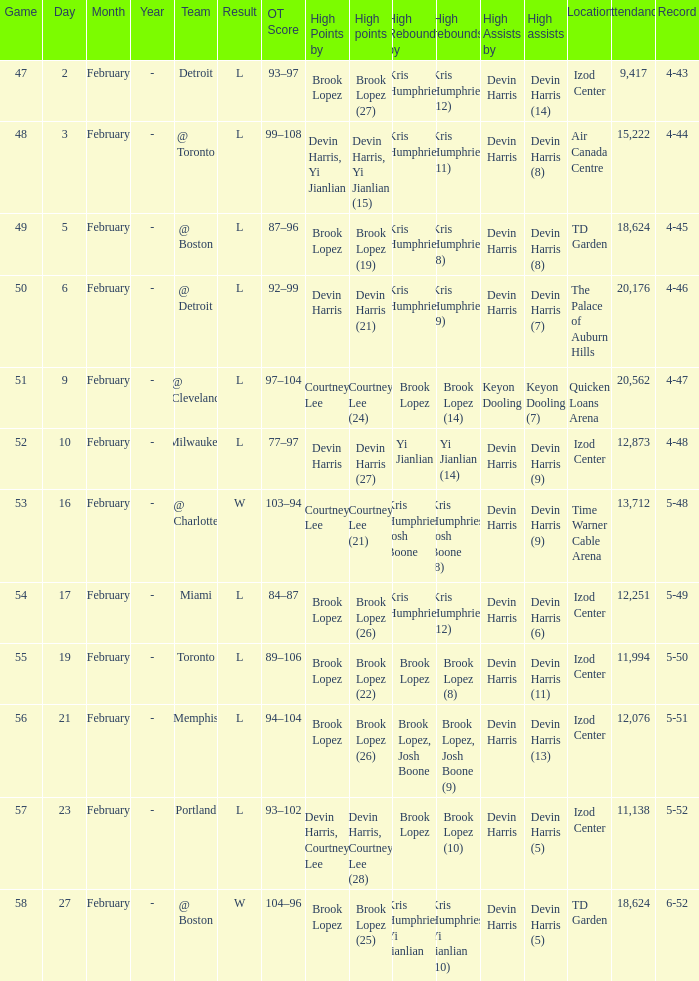Who did the high assists in the game played on February 9? Keyon Dooling (7). 